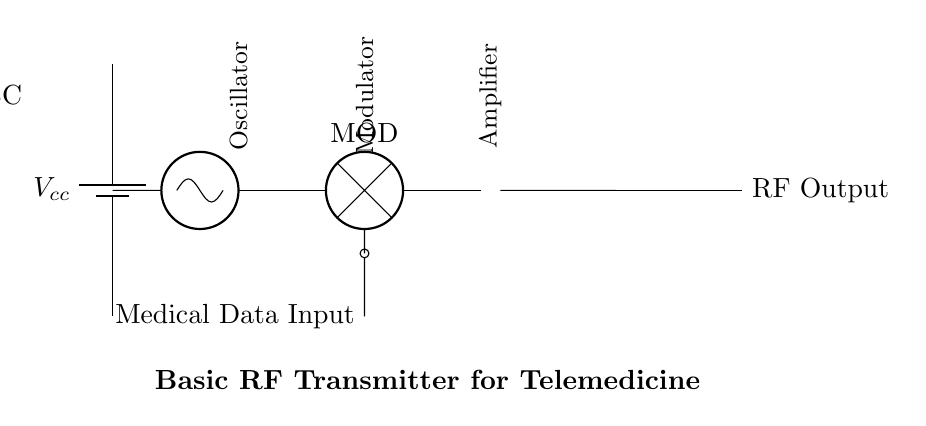What is the main function of the oscillator in this circuit? The oscillator generates a carrier wave signal that modulates the medical data, enabling transmission over RF frequencies.
Answer: Carrier wave generator What type of data is inputted into the modulator? The modulator takes medical data as input, which is then superimposed onto the carrier wave for transmission.
Answer: Medical data How many stages are present in this RF transmitter circuit? There are four stages: power supply, oscillator, modulator, and amplifier. These stages are essential for the transmittal of modulated signals.
Answer: Four What is the role of the amplifier in this circuit? The amplifier increases the strength of the modulated signal before it is sent out through the antenna, ensuring better transmission distance and clarity.
Answer: Signal strengthening Which component directly connects to the antenna for RF output? The output from the amplifier is directly connected to the antenna to transmit the modulated RF signal.
Answer: Amplifier What is the purpose of the battery in this circuit? The battery serves as the power supply, providing necessary voltage and current to the various components within the transmitter circuit.
Answer: Power supply What type of modulation is implied in this RF transmitter circuit? The combination of the data input and the oscillator suggests amplitude modulation is being used to encode the medical data onto the carrier wave.
Answer: Amplitude modulation 